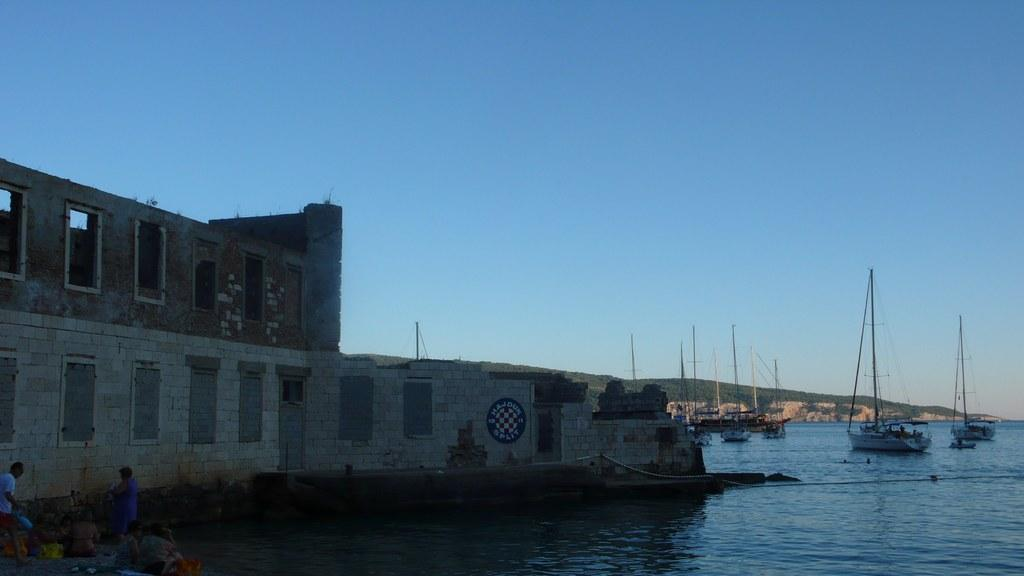What is located beside the river in the image? There is a big building beside the river in the image. What can be seen in the river? There are boats in the river. What natural feature is visible in the background of the image? There is a mountain visible in the image. What are the people in the image doing? People are sitting at the bank of the river. What color is the suit worn by the mountain in the image? There is no suit or color associated with the mountain in the image, as it is a natural feature. 